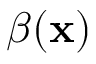<formula> <loc_0><loc_0><loc_500><loc_500>\beta ( x )</formula> 